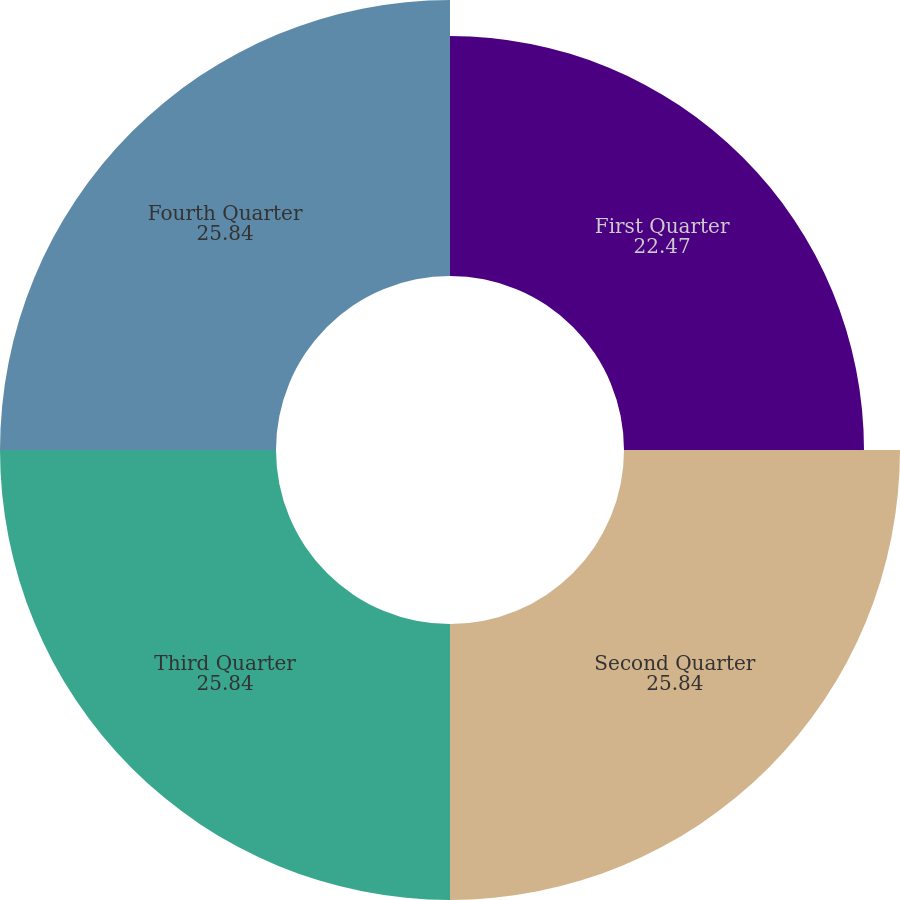Convert chart to OTSL. <chart><loc_0><loc_0><loc_500><loc_500><pie_chart><fcel>First Quarter<fcel>Second Quarter<fcel>Third Quarter<fcel>Fourth Quarter<nl><fcel>22.47%<fcel>25.84%<fcel>25.84%<fcel>25.84%<nl></chart> 